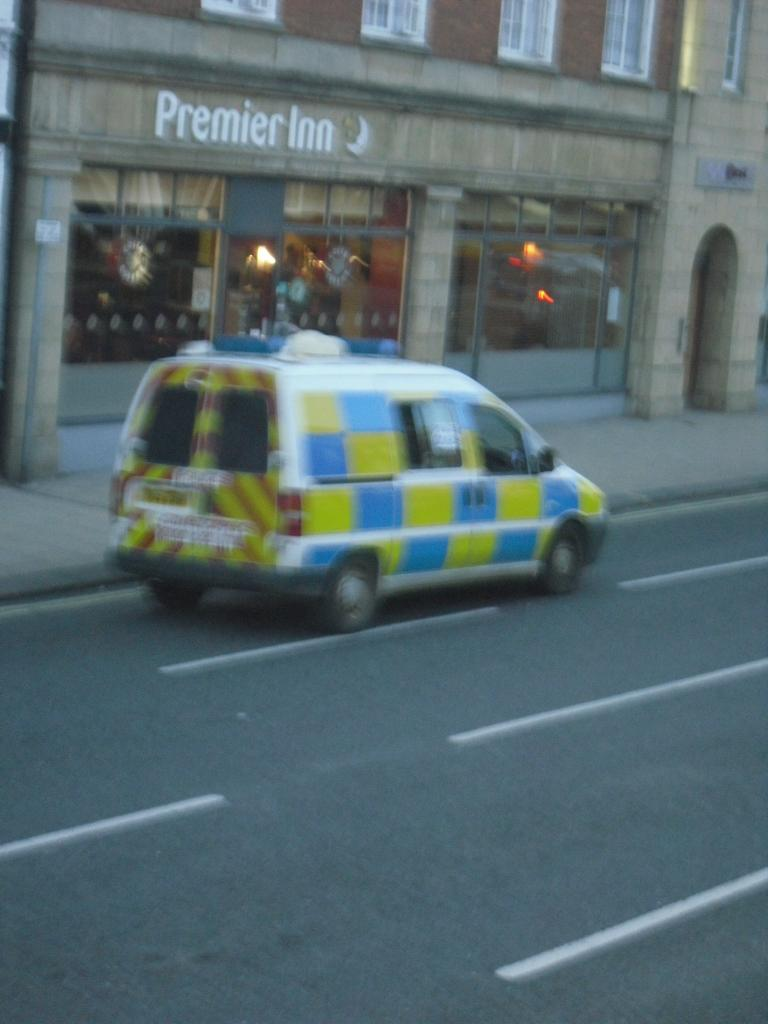What is the main subject of the image? There is a car on the road in the image. What else can be seen in the image besides the car? There is a building in the image. What feature of the building is mentioned in the facts? The building has windows. Can you describe the light in the image? There is a light in the image. What other objects are present in the image? There are objects in the image. What type of poison can be seen coming out of the car's exhaust in the image? There is no poison or exhaust visible in the image; it only shows a car on the road, a building, and a light. 